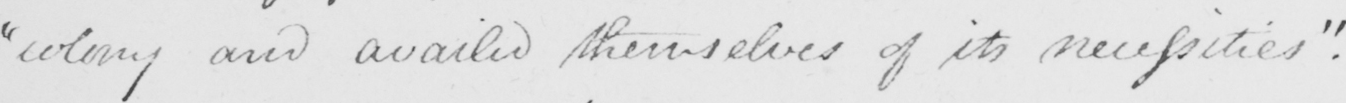What text is written in this handwritten line? colony and availed themselves of its necessities . _ 